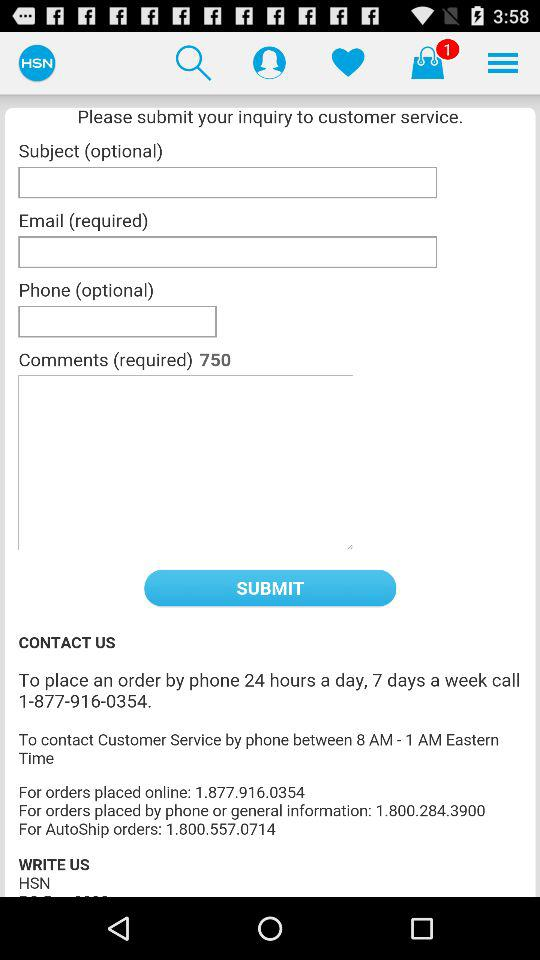When can the order be placed? The order can be placed 24 hours a day, 7 days a week. 